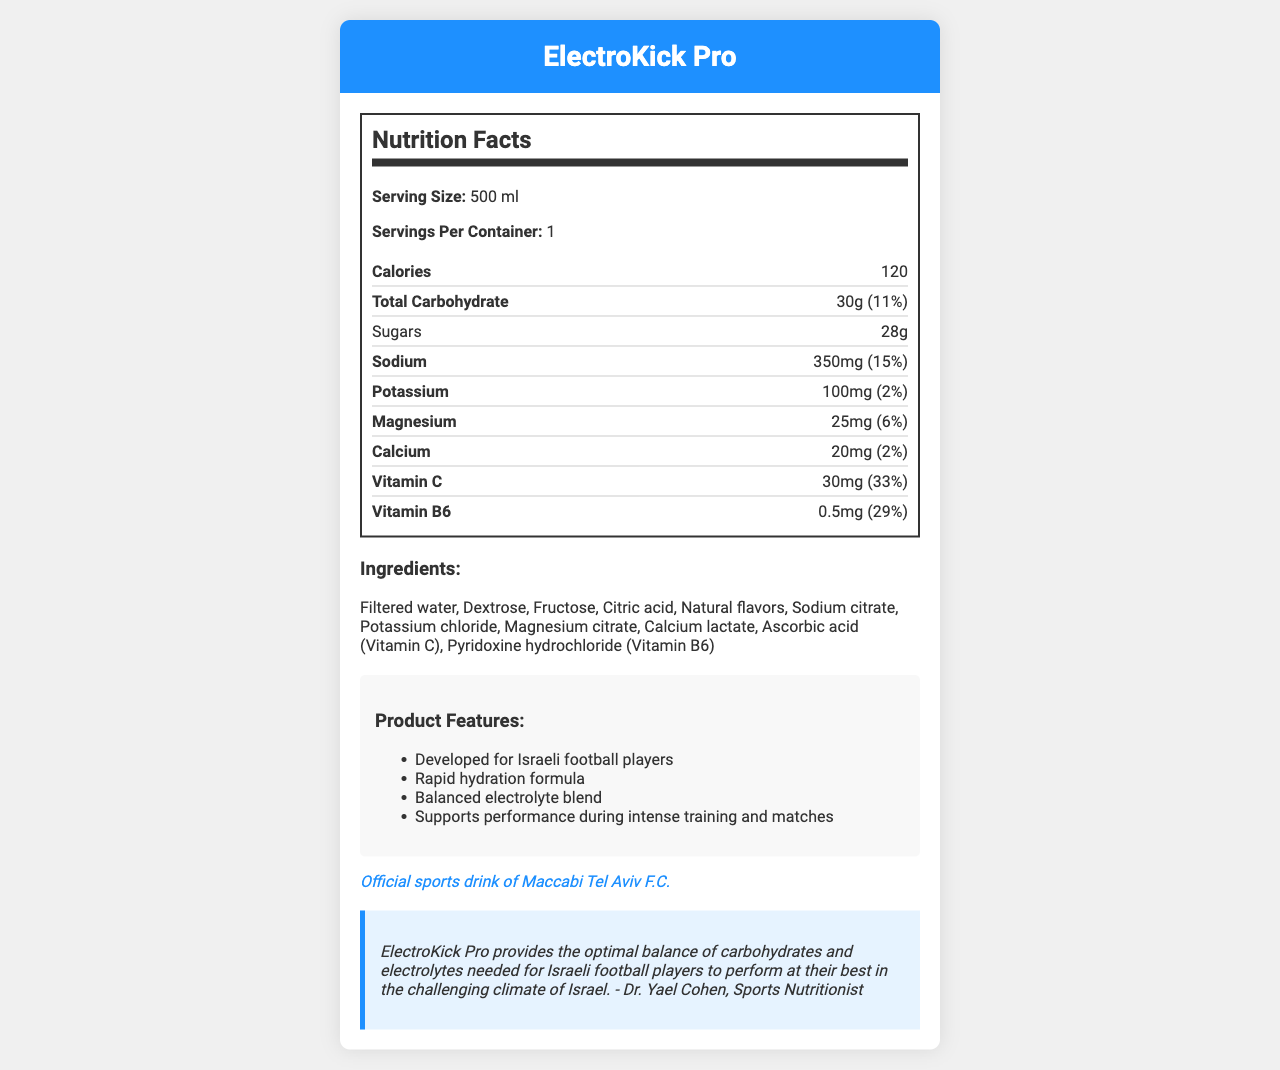how many calories are in one serving of ElectroKick Pro? According to the nutrition label, each serving of ElectroKick Pro contains 120 calories.
Answer: 120 what are the main electrolytes listed in the nutrition facts? The nutrition label lists Sodium, Potassium, Magnesium, and Calcium as the main electrolytes.
Answer: Sodium, Potassium, Magnesium, Calcium how much sodium does a single serving contain? The label indicates that one serving contains 350 mg of sodium.
Answer: 350 mg what percentage of the daily value for vitamin C does ElectroKick Pro contain? The label shows that one serving of ElectroKick Pro provides 33% of the daily value for vitamin C.
Answer: 33% what is the serving size for ElectroKick Pro? According to the nutrition facts, the serving size is 500 ml.
Answer: 500 ml which vitamin has the highest percentage of daily value in ElectroKick Pro? A. Vitamin C B. Vitamin B6 C. Vitamin D D. Vitamin A The nutrition label states that Vitamin C has a daily value percentage of 33%, which is the highest among the listed vitamins.
Answer: A. Vitamin C how much sugar is in one serving of ElectroKick Pro? The nutrition label shows that there are 28 g of sugar per serving.
Answer: 28 g ElectroKick Pro is designed specifically for which type of athletes? The marketing claims indicate that ElectroKick Pro is developed for Israeli football players.
Answer: Israeli football players does one serving of ElectroKick Pro provide a significant amount of potassium? One serving provides 100 mg of potassium, which is only 2% of the daily value, considered relatively low.
Answer: No which club officially endorses ElectroKick Pro? A. Hapoel Tel Aviv F.C. B. Beitar Jerusalem F.C. C. Maccabi Tel Aviv F.C. The endorsement claim states that ElectroKick Pro is the official sports drink of Maccabi Tel Aviv F.C.
Answer: C. Maccabi Tel Aviv F.C. how many servings are there in one container of ElectroKick Pro? The label states that there is one serving per container.
Answer: 1 is there any ingredient in ElectroKick Pro that is an artificial flavor? The list of ingredients mentions "Natural flavors," implying no artificial flavors are included.
Answer: No what is the main function of ElectroKick Pro according to the marketing claims? The marketing claims state that ElectroKick Pro is designed for rapid hydration and to support performance during intense training and matches.
Answer: Rapid hydration and supporting performance during intense training and matches how does the sports nutritionist describe the benefits of ElectroKick Pro for Israeli football players? The quote from the sports nutritionist explains that ElectroKick Pro offers the optimal balance of carbohydrates and electrolytes needed for athletes to perform well in Israel's climate.
Answer: Provides optimal balance of carbohydrates and electrolytes for performance in Israel's climate what percentage of the daily value for magnesium is provided by ElectroKick Pro? The label shows that one serving provides 25 mg of magnesium, which corresponds to 6% of the daily value.
Answer: 6% summarize the key information and purpose of the ElectroKick Pro document. The document provides detailed nutrition facts, key ingredients, and the endorsement by Maccabi Tel Aviv F.C., highlighting the product's benefits for hydration and athletic performance backed by a sports nutritionist.
Answer: ElectroKick Pro is a sports drink specifically developed for Israeli football players, endorsed by Maccabi Tel Aviv F.C. It provides essential electrolytes like sodium, potassium, magnesium, and calcium, along with vitamins C and B6. Each 500 ml serving contains 120 calories, 30g of carbohydrates, and 28g of sugar. It's designed to aid hydration and performance during intense training and matches. can the label provide the total protein content in ElectroKick Pro? The label does not mention any details about protein content, so it cannot be determined from the given information.
Answer: Not enough information 